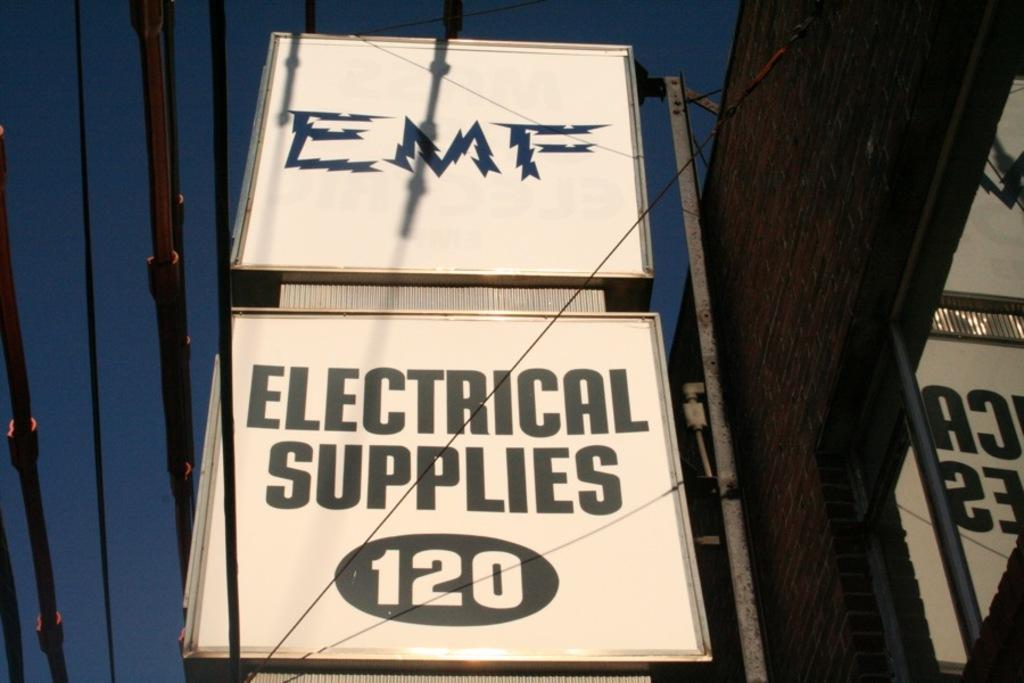<image>
Offer a succinct explanation of the picture presented. Two square billboards: the bottom one reads "Electrical Supplies (120)", the top has the letters "EMF" 